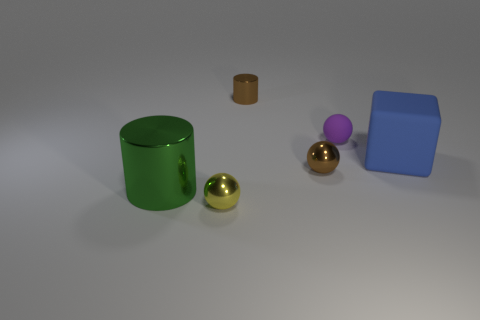There is another small metal thing that is the same shape as the yellow object; what color is it?
Make the answer very short. Brown. There is a shiny object that is behind the green metallic cylinder and in front of the tiny cylinder; how big is it?
Give a very brief answer. Small. There is a large rubber object that is to the right of the small yellow object; is it the same shape as the object that is behind the purple sphere?
Provide a succinct answer. No. What is the shape of the object that is the same color as the tiny metallic cylinder?
Ensure brevity in your answer.  Sphere. How many tiny brown objects are made of the same material as the brown cylinder?
Give a very brief answer. 1. What is the shape of the tiny object that is both in front of the tiny matte sphere and behind the big metal cylinder?
Your response must be concise. Sphere. Do the cylinder behind the large blue object and the large green cylinder have the same material?
Your answer should be very brief. Yes. Is there any other thing that is the same material as the small yellow ball?
Make the answer very short. Yes. What is the color of the other shiny ball that is the same size as the brown metal ball?
Ensure brevity in your answer.  Yellow. Are there any tiny metallic balls of the same color as the large metal object?
Give a very brief answer. No. 